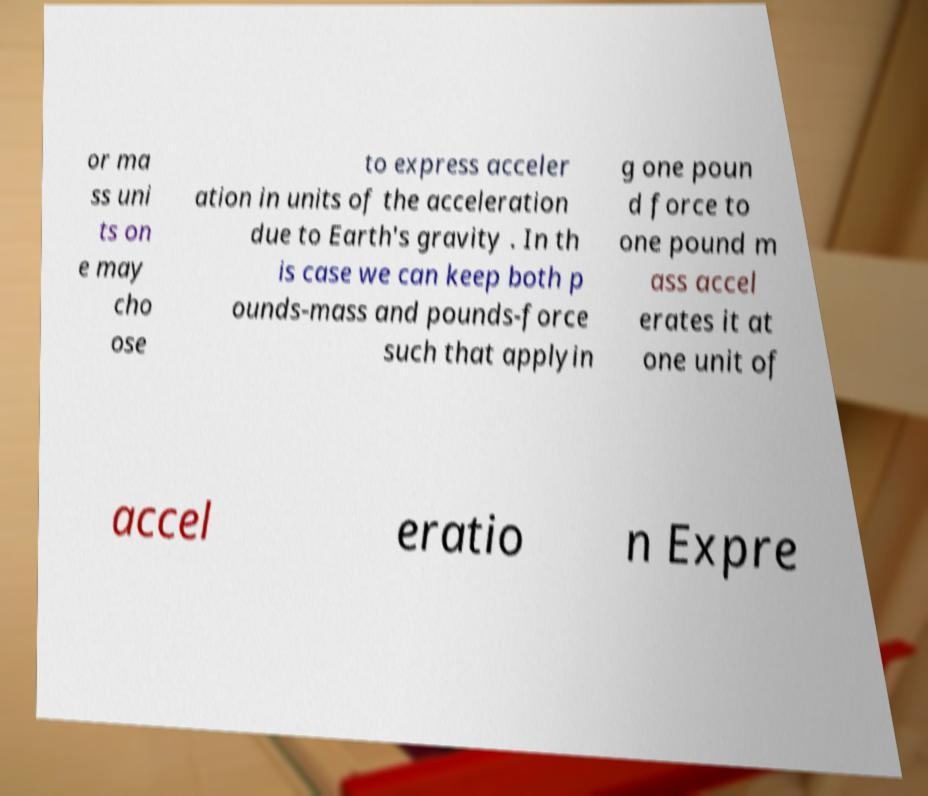Could you assist in decoding the text presented in this image and type it out clearly? or ma ss uni ts on e may cho ose to express acceler ation in units of the acceleration due to Earth's gravity . In th is case we can keep both p ounds-mass and pounds-force such that applyin g one poun d force to one pound m ass accel erates it at one unit of accel eratio n Expre 